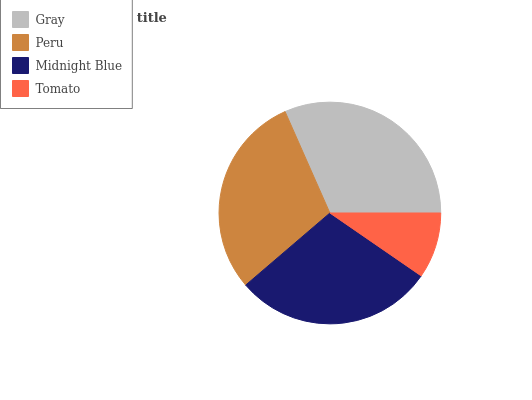Is Tomato the minimum?
Answer yes or no. Yes. Is Gray the maximum?
Answer yes or no. Yes. Is Peru the minimum?
Answer yes or no. No. Is Peru the maximum?
Answer yes or no. No. Is Gray greater than Peru?
Answer yes or no. Yes. Is Peru less than Gray?
Answer yes or no. Yes. Is Peru greater than Gray?
Answer yes or no. No. Is Gray less than Peru?
Answer yes or no. No. Is Peru the high median?
Answer yes or no. Yes. Is Midnight Blue the low median?
Answer yes or no. Yes. Is Gray the high median?
Answer yes or no. No. Is Peru the low median?
Answer yes or no. No. 